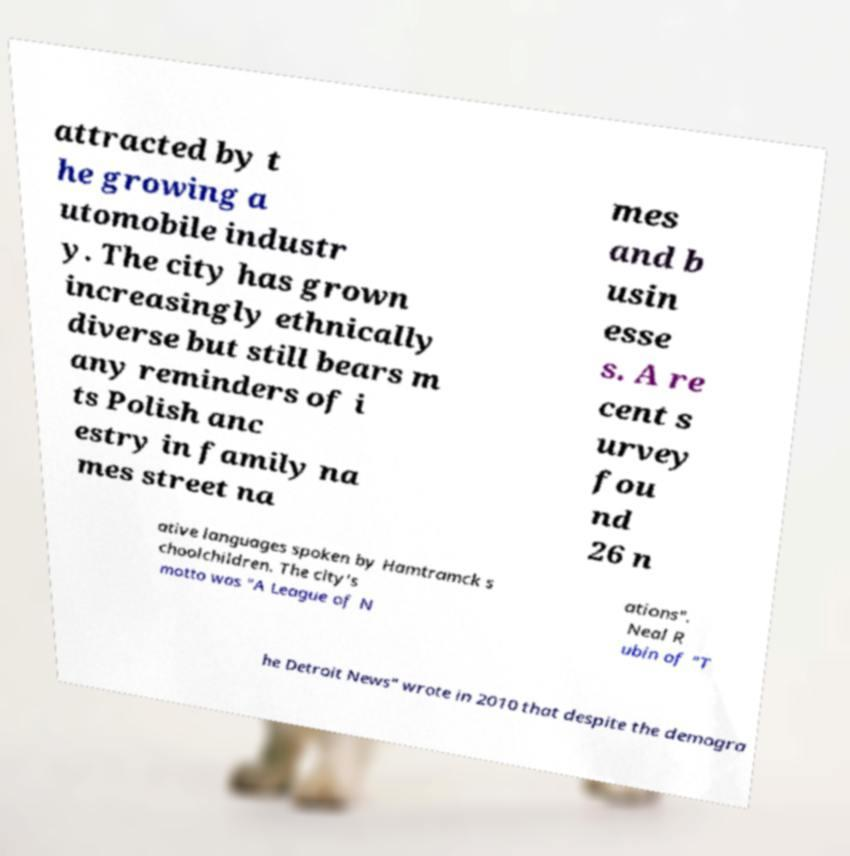Could you assist in decoding the text presented in this image and type it out clearly? attracted by t he growing a utomobile industr y. The city has grown increasingly ethnically diverse but still bears m any reminders of i ts Polish anc estry in family na mes street na mes and b usin esse s. A re cent s urvey fou nd 26 n ative languages spoken by Hamtramck s choolchildren. The city's motto was "A League of N ations". Neal R ubin of "T he Detroit News" wrote in 2010 that despite the demogra 